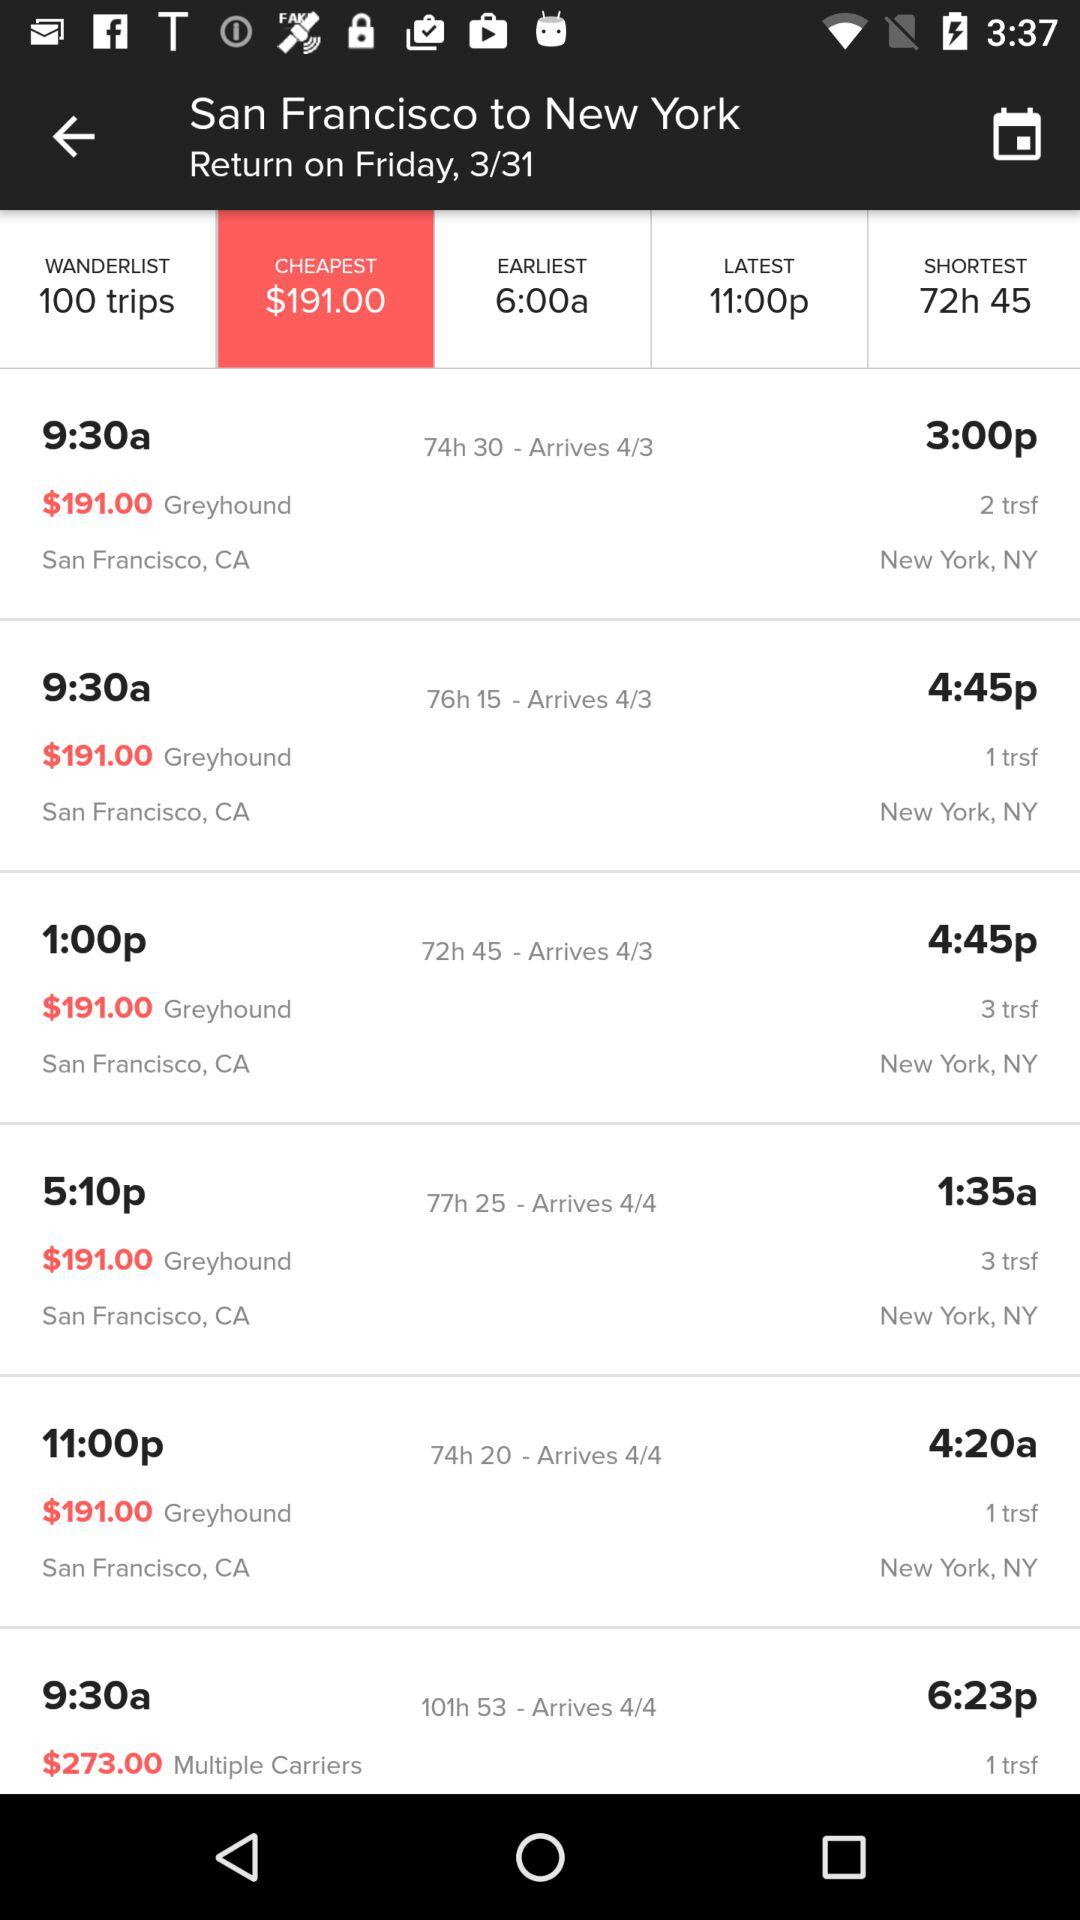How much more expensive is the most expensive flight than the cheapest flight?
Answer the question using a single word or phrase. $82.00 